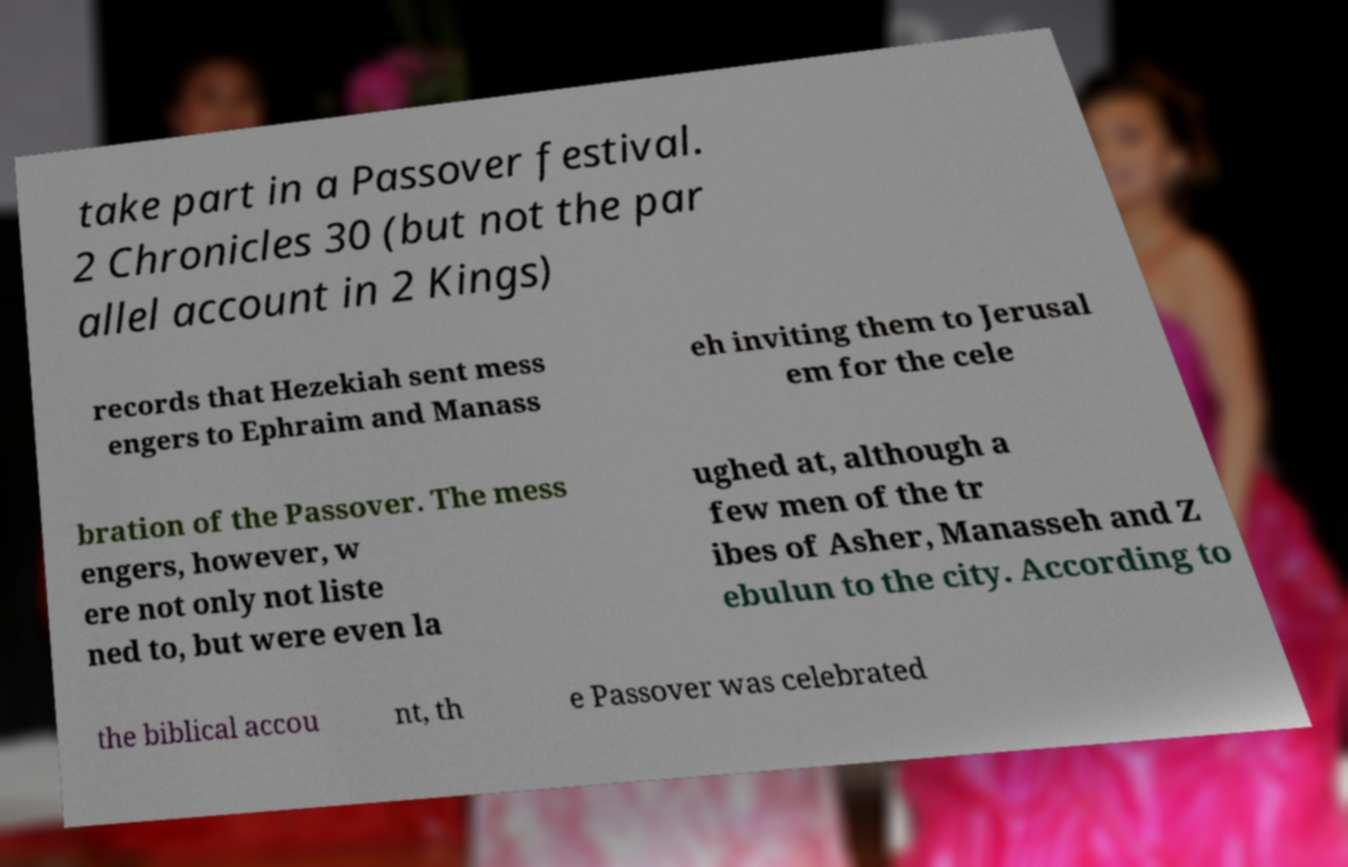Please identify and transcribe the text found in this image. take part in a Passover festival. 2 Chronicles 30 (but not the par allel account in 2 Kings) records that Hezekiah sent mess engers to Ephraim and Manass eh inviting them to Jerusal em for the cele bration of the Passover. The mess engers, however, w ere not only not liste ned to, but were even la ughed at, although a few men of the tr ibes of Asher, Manasseh and Z ebulun to the city. According to the biblical accou nt, th e Passover was celebrated 